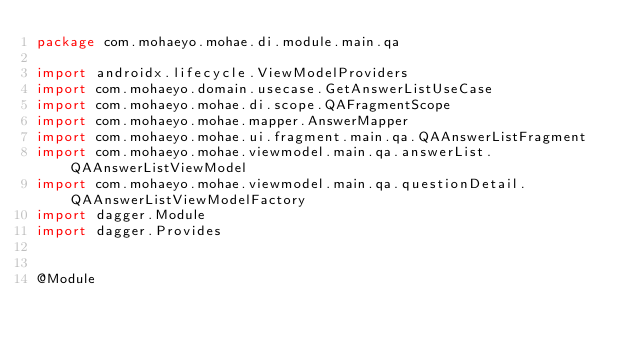<code> <loc_0><loc_0><loc_500><loc_500><_Kotlin_>package com.mohaeyo.mohae.di.module.main.qa

import androidx.lifecycle.ViewModelProviders
import com.mohaeyo.domain.usecase.GetAnswerListUseCase
import com.mohaeyo.mohae.di.scope.QAFragmentScope
import com.mohaeyo.mohae.mapper.AnswerMapper
import com.mohaeyo.mohae.ui.fragment.main.qa.QAAnswerListFragment
import com.mohaeyo.mohae.viewmodel.main.qa.answerList.QAAnswerListViewModel
import com.mohaeyo.mohae.viewmodel.main.qa.questionDetail.QAAnswerListViewModelFactory
import dagger.Module
import dagger.Provides


@Module</code> 